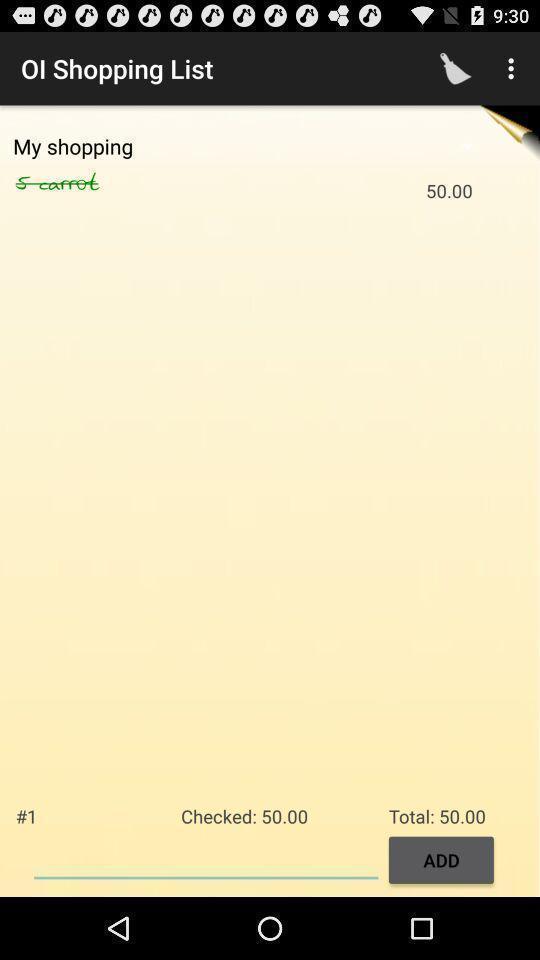Summarize the main components in this picture. Page to add in the shopping checklist app. 